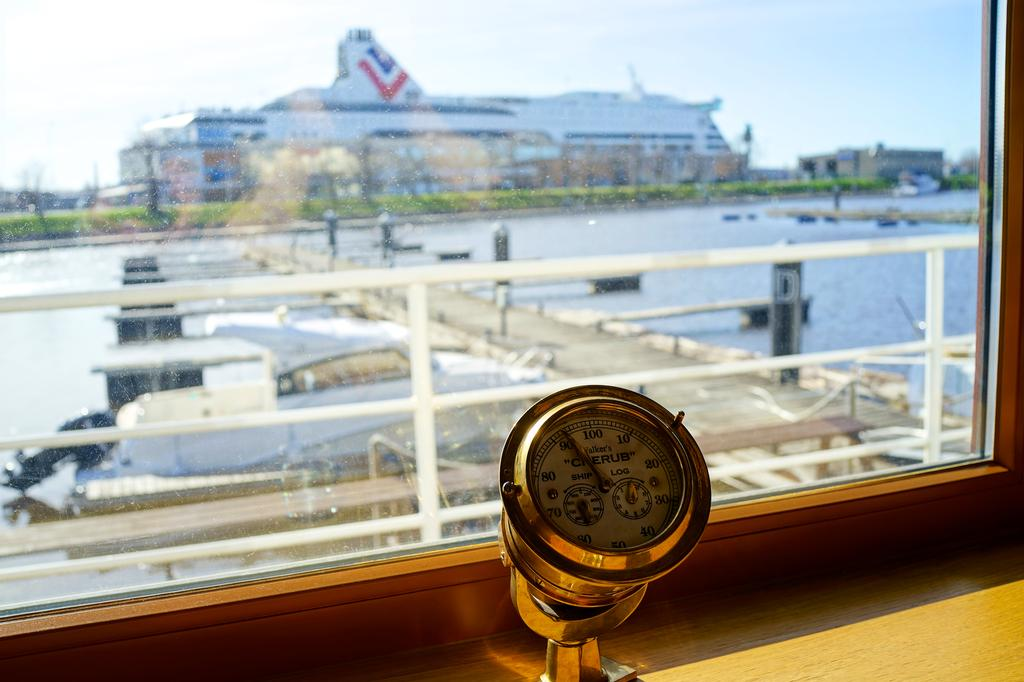<image>
Describe the image concisely. a boat has a device called Cherub and it has numbers on it 